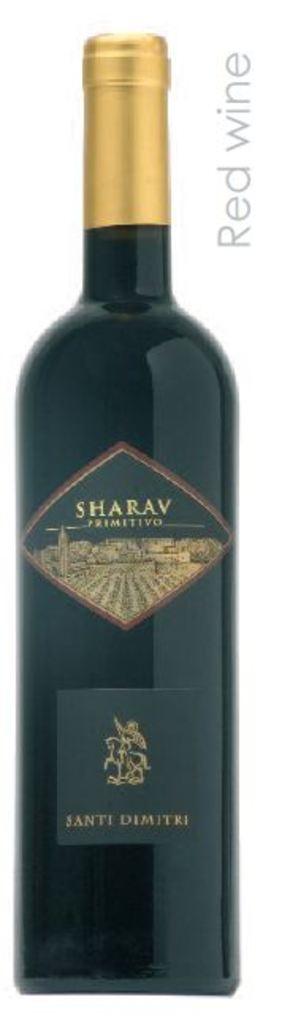What does it say on the black sticker?
Ensure brevity in your answer.  Santi dimitri. 